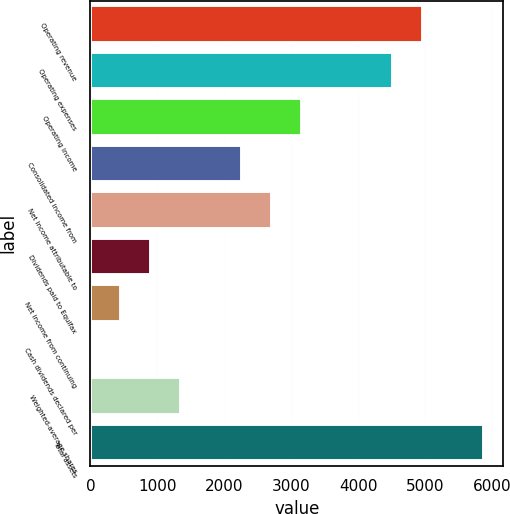<chart> <loc_0><loc_0><loc_500><loc_500><bar_chart><fcel>Operating revenue<fcel>Operating expenses<fcel>Operating income<fcel>Consolidated income from<fcel>Net income attributable to<fcel>Dividends paid to Equifax<fcel>Net income from continuing<fcel>Cash dividends declared per<fcel>Weighted-average shares<fcel>Total assets<nl><fcel>4974.64<fcel>4522.48<fcel>3166<fcel>2261.68<fcel>2713.84<fcel>905.2<fcel>453.04<fcel>0.88<fcel>1357.36<fcel>5878.96<nl></chart> 